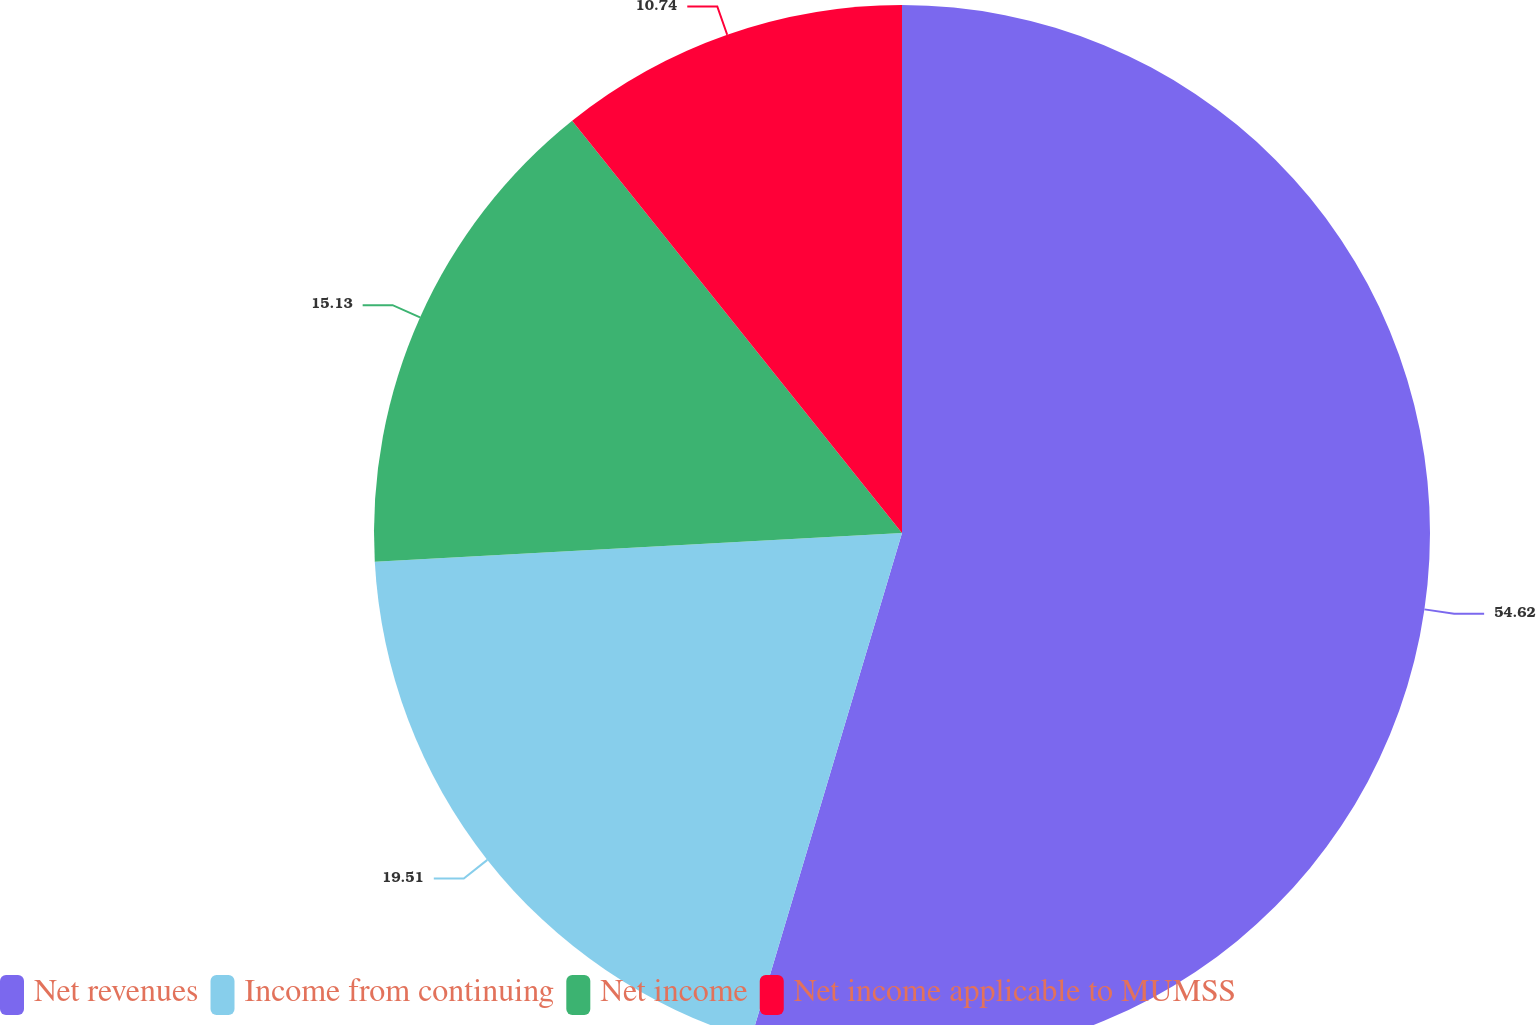Convert chart to OTSL. <chart><loc_0><loc_0><loc_500><loc_500><pie_chart><fcel>Net revenues<fcel>Income from continuing<fcel>Net income<fcel>Net income applicable to MUMSS<nl><fcel>54.62%<fcel>19.51%<fcel>15.13%<fcel>10.74%<nl></chart> 